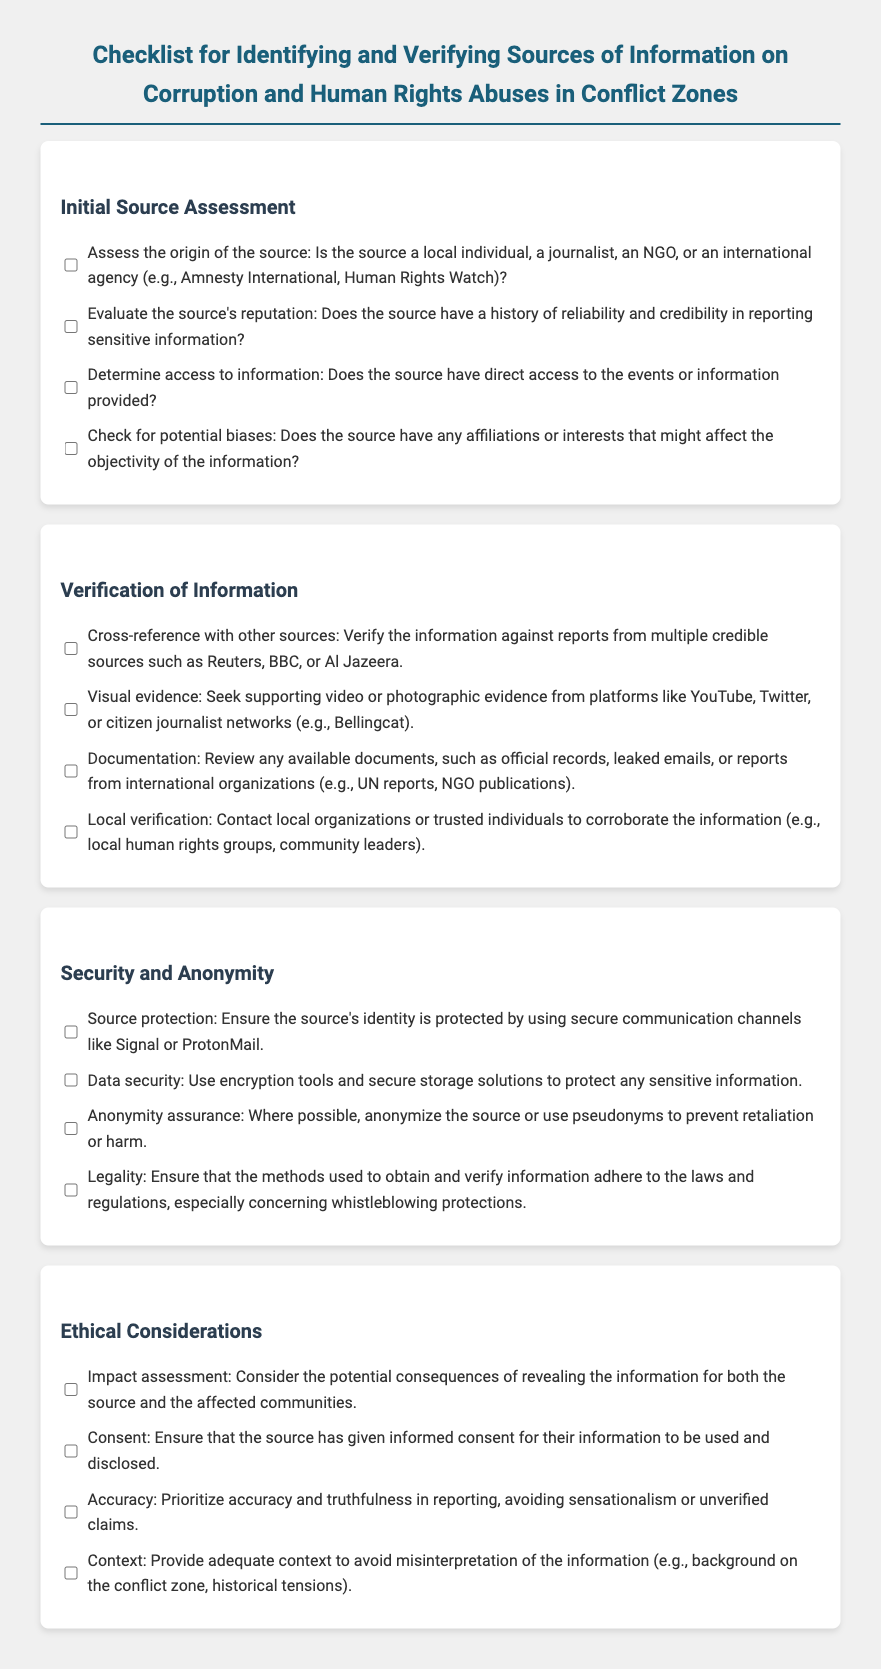What are the main sections of the checklist? The checklist is divided into four main sections: Initial Source Assessment, Verification of Information, Security and Anonymity, and Ethical Considerations.
Answer: Initial Source Assessment, Verification of Information, Security and Anonymity, Ethical Considerations How many items are there in the 'Verification of Information' section? The 'Verification of Information' section contains four items for consideration.
Answer: 4 What is the purpose of assessing the origin of the source? It helps in determining whether the source is credible based on their background, such as being a local individual, journalist, NGO, or agency.
Answer: Assess the credibility Which checkbox item deals with ensuring the source is protected? The item that addresses source protection suggests using secure communication channels.
Answer: Source protection What is one of the suggested methods for local verification? The checklist recommends contacting local organizations or trusted individuals to corroborate the information.
Answer: Contact local organizations What is the focus of the 'Ethical Considerations' section? This section emphasizes evaluating the impact, consent, accuracy, and context of the information being reported.
Answer: Evaluating impact, consent, accuracy, context What type of evidence is suggested for verification? The checklist advises seeking supporting video or photographic evidence from platforms like YouTube or Twitter.
Answer: Video or photographic evidence What is one potential consequence of revealing information mentioned in the document? The checklist highlights the potential consequences for both the source and affected communities as an impact assessment consideration.
Answer: Potential consequences 